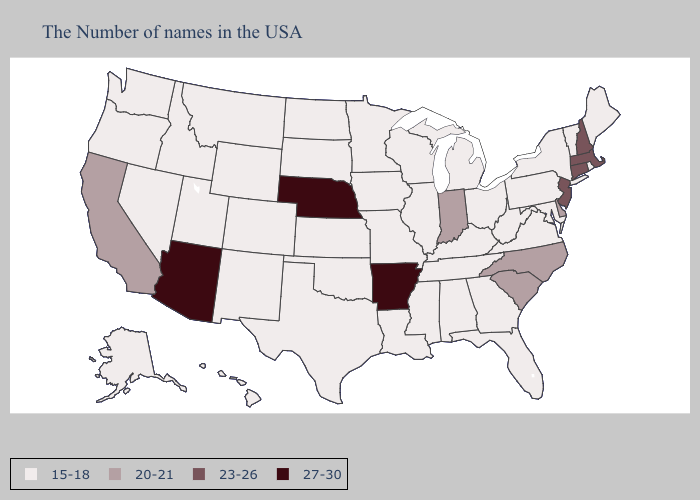What is the value of Vermont?
Answer briefly. 15-18. Does Nebraska have the lowest value in the USA?
Quick response, please. No. Does Delaware have the lowest value in the USA?
Give a very brief answer. No. Name the states that have a value in the range 27-30?
Give a very brief answer. Arkansas, Nebraska, Arizona. Which states have the highest value in the USA?
Be succinct. Arkansas, Nebraska, Arizona. Which states have the highest value in the USA?
Give a very brief answer. Arkansas, Nebraska, Arizona. Name the states that have a value in the range 23-26?
Concise answer only. Massachusetts, New Hampshire, Connecticut, New Jersey. What is the highest value in the USA?
Write a very short answer. 27-30. Does New Jersey have the lowest value in the USA?
Quick response, please. No. Does Ohio have the lowest value in the USA?
Short answer required. Yes. What is the highest value in the West ?
Short answer required. 27-30. What is the lowest value in the MidWest?
Concise answer only. 15-18. Among the states that border Maine , which have the lowest value?
Quick response, please. New Hampshire. What is the value of Illinois?
Be succinct. 15-18. Does Georgia have the lowest value in the South?
Keep it brief. Yes. 